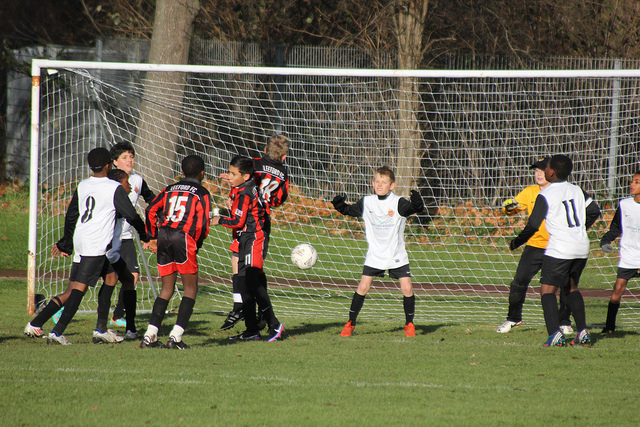Identify the text displayed in this image. 15 8 11 